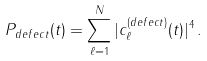Convert formula to latex. <formula><loc_0><loc_0><loc_500><loc_500>P _ { d e f e c t } ( t ) = \sum _ { \ell = 1 } ^ { N } | c _ { \ell } ^ { ( d e f e c t ) } ( t ) | ^ { 4 } \, .</formula> 